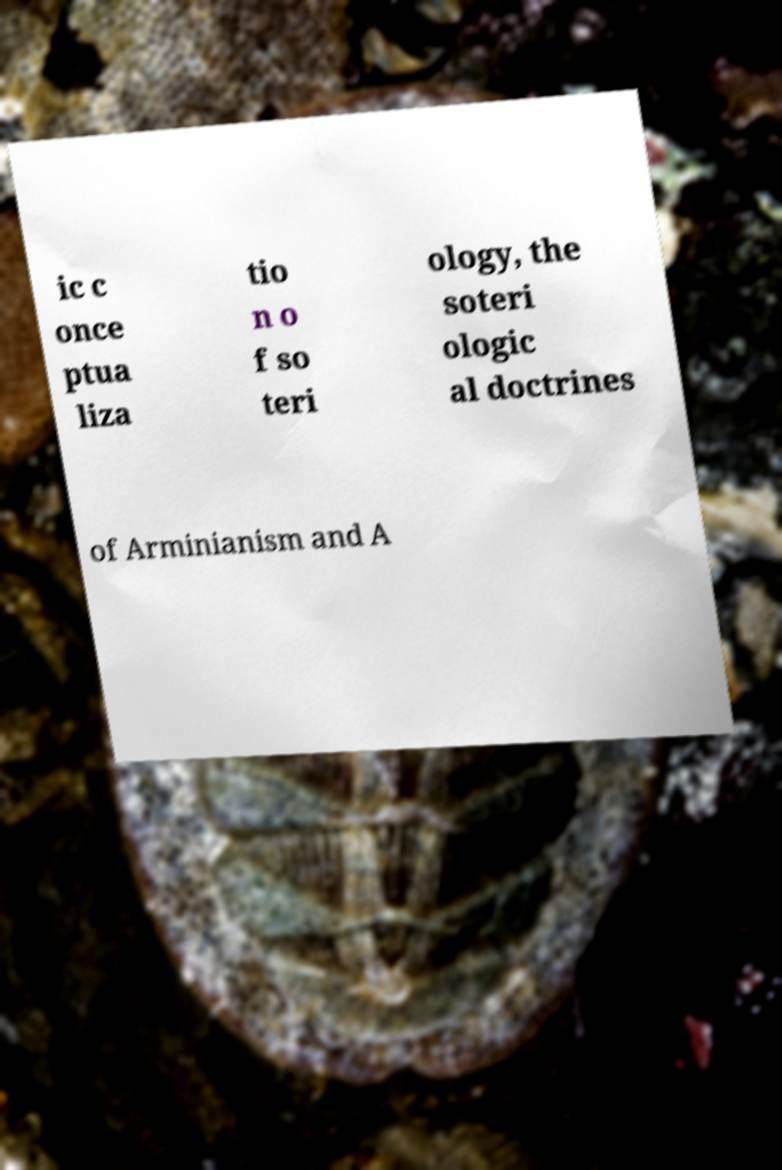Please identify and transcribe the text found in this image. ic c once ptua liza tio n o f so teri ology, the soteri ologic al doctrines of Arminianism and A 